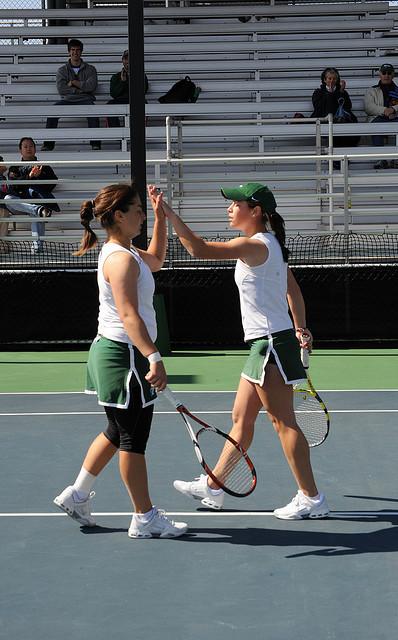What is the color of the skirts they are wearing?
Be succinct. Green. Is the match over?
Concise answer only. Yes. Are they playing tennis?
Answer briefly. Yes. 